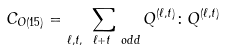Convert formula to latex. <formula><loc_0><loc_0><loc_500><loc_500>C _ { O ( 1 5 ) } = \sum _ { \ell , t , \ \ell + t \ o d d } Q ^ { ( \ell , t ) } \colon Q ^ { ( \ell , t ) }</formula> 